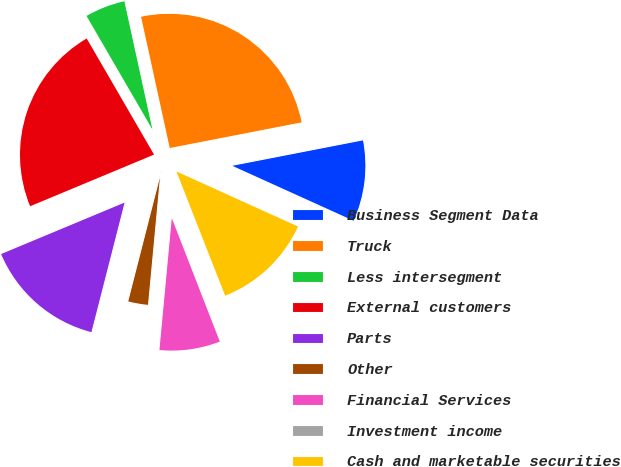Convert chart. <chart><loc_0><loc_0><loc_500><loc_500><pie_chart><fcel>Business Segment Data<fcel>Truck<fcel>Less intersegment<fcel>External customers<fcel>Parts<fcel>Other<fcel>Financial Services<fcel>Investment income<fcel>Cash and marketable securities<nl><fcel>9.83%<fcel>25.37%<fcel>4.94%<fcel>22.92%<fcel>14.73%<fcel>2.5%<fcel>7.39%<fcel>0.05%<fcel>12.28%<nl></chart> 